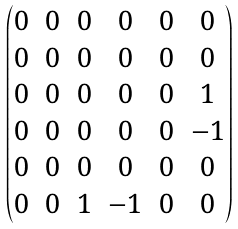Convert formula to latex. <formula><loc_0><loc_0><loc_500><loc_500>\begin{pmatrix} 0 & 0 & 0 & 0 & 0 & 0 \\ 0 & 0 & 0 & 0 & 0 & 0 \\ 0 & 0 & 0 & 0 & 0 & 1 \\ 0 & 0 & 0 & 0 & 0 & - 1 \\ 0 & 0 & 0 & 0 & 0 & 0 \\ 0 & 0 & 1 & - 1 & 0 & 0 \end{pmatrix}</formula> 